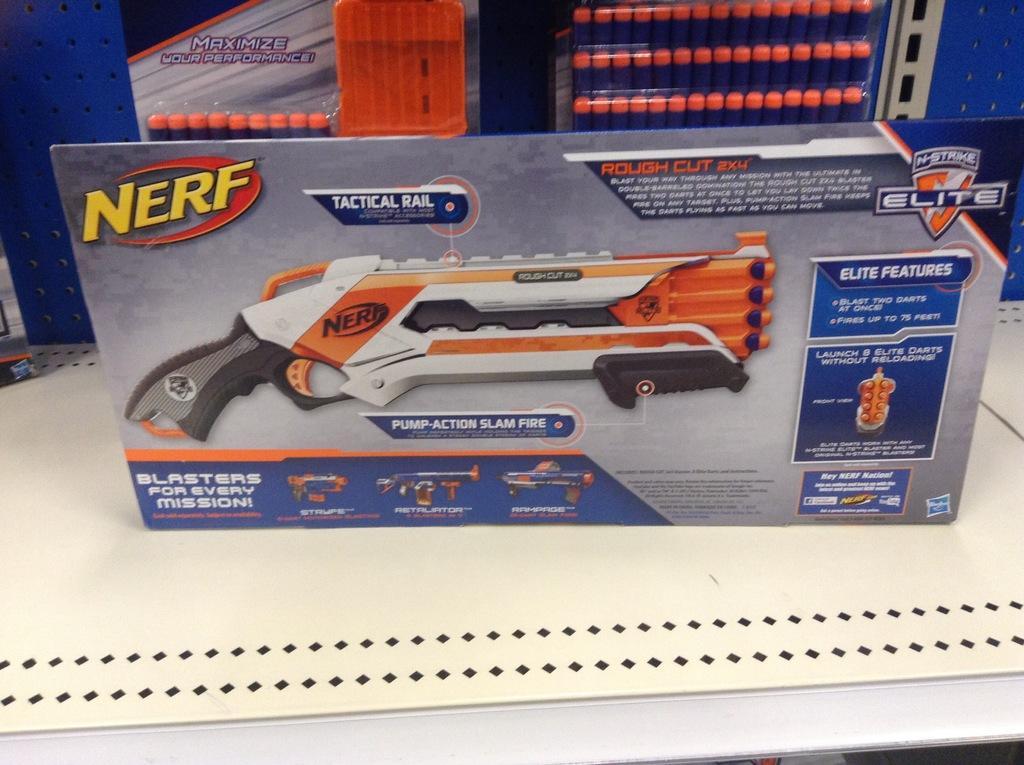Can you describe this image briefly? In the image there are some objects kept on a table. 